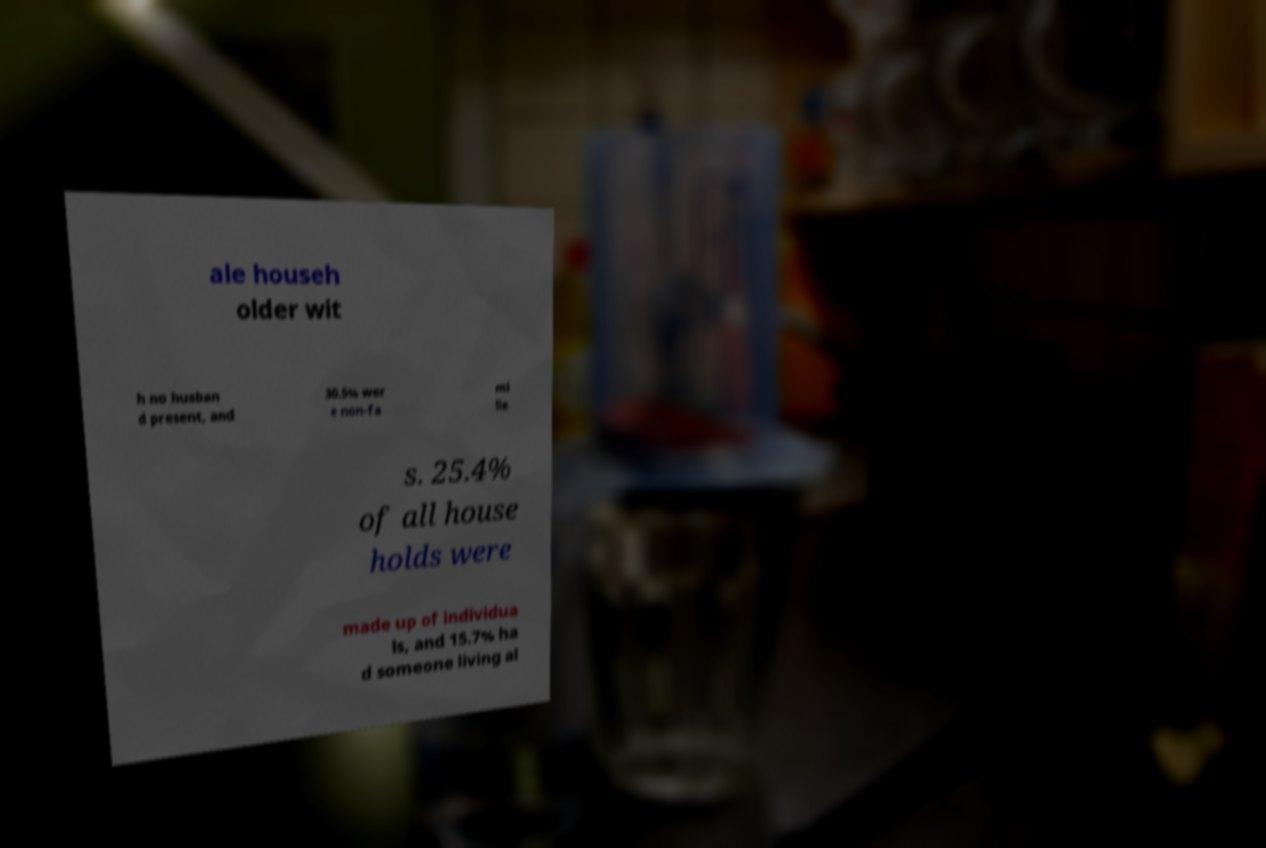Please identify and transcribe the text found in this image. ale househ older wit h no husban d present, and 30.5% wer e non-fa mi lie s. 25.4% of all house holds were made up of individua ls, and 15.7% ha d someone living al 